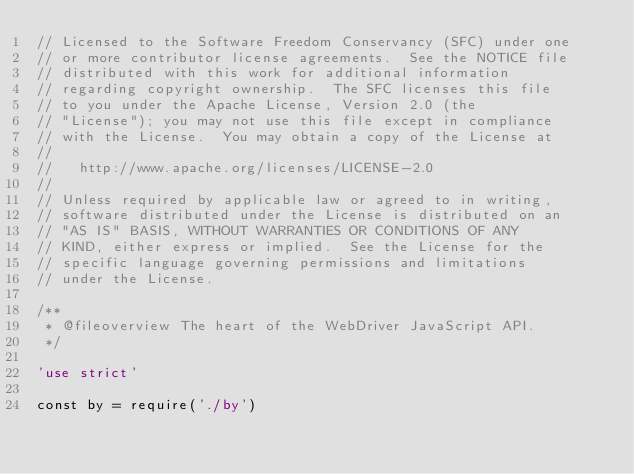Convert code to text. <code><loc_0><loc_0><loc_500><loc_500><_JavaScript_>// Licensed to the Software Freedom Conservancy (SFC) under one
// or more contributor license agreements.  See the NOTICE file
// distributed with this work for additional information
// regarding copyright ownership.  The SFC licenses this file
// to you under the Apache License, Version 2.0 (the
// "License"); you may not use this file except in compliance
// with the License.  You may obtain a copy of the License at
//
//   http://www.apache.org/licenses/LICENSE-2.0
//
// Unless required by applicable law or agreed to in writing,
// software distributed under the License is distributed on an
// "AS IS" BASIS, WITHOUT WARRANTIES OR CONDITIONS OF ANY
// KIND, either express or implied.  See the License for the
// specific language governing permissions and limitations
// under the License.

/**
 * @fileoverview The heart of the WebDriver JavaScript API.
 */

'use strict'

const by = require('./by')</code> 